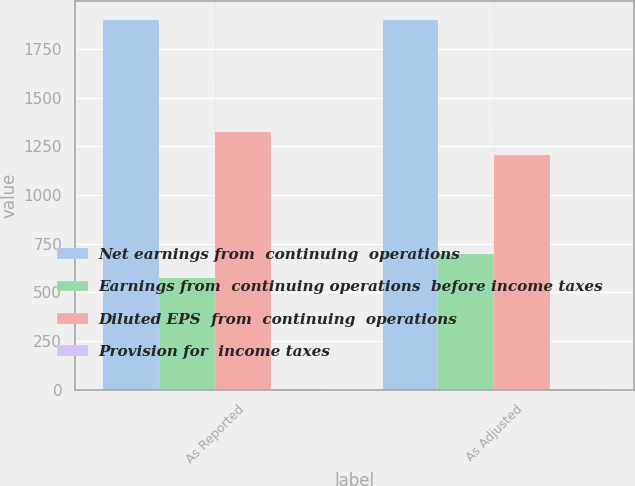<chart> <loc_0><loc_0><loc_500><loc_500><stacked_bar_chart><ecel><fcel>As Reported<fcel>As Adjusted<nl><fcel>Net earnings from  continuing  operations<fcel>1900.1<fcel>1900.1<nl><fcel>Earnings from  continuing operations  before income taxes<fcel>575<fcel>695<nl><fcel>Diluted EPS  from  continuing  operations<fcel>1325.1<fcel>1205.1<nl><fcel>Provision for  income taxes<fcel>2.62<fcel>2.38<nl></chart> 